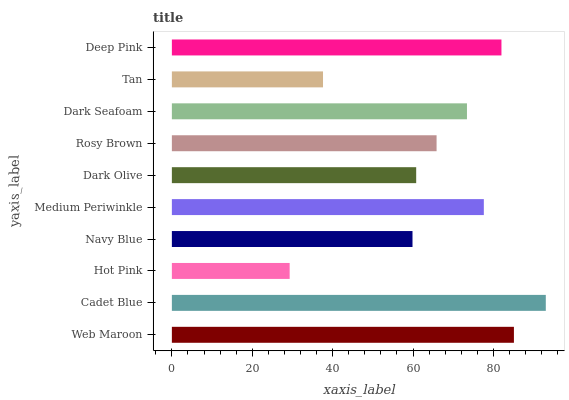Is Hot Pink the minimum?
Answer yes or no. Yes. Is Cadet Blue the maximum?
Answer yes or no. Yes. Is Cadet Blue the minimum?
Answer yes or no. No. Is Hot Pink the maximum?
Answer yes or no. No. Is Cadet Blue greater than Hot Pink?
Answer yes or no. Yes. Is Hot Pink less than Cadet Blue?
Answer yes or no. Yes. Is Hot Pink greater than Cadet Blue?
Answer yes or no. No. Is Cadet Blue less than Hot Pink?
Answer yes or no. No. Is Dark Seafoam the high median?
Answer yes or no. Yes. Is Rosy Brown the low median?
Answer yes or no. Yes. Is Tan the high median?
Answer yes or no. No. Is Navy Blue the low median?
Answer yes or no. No. 